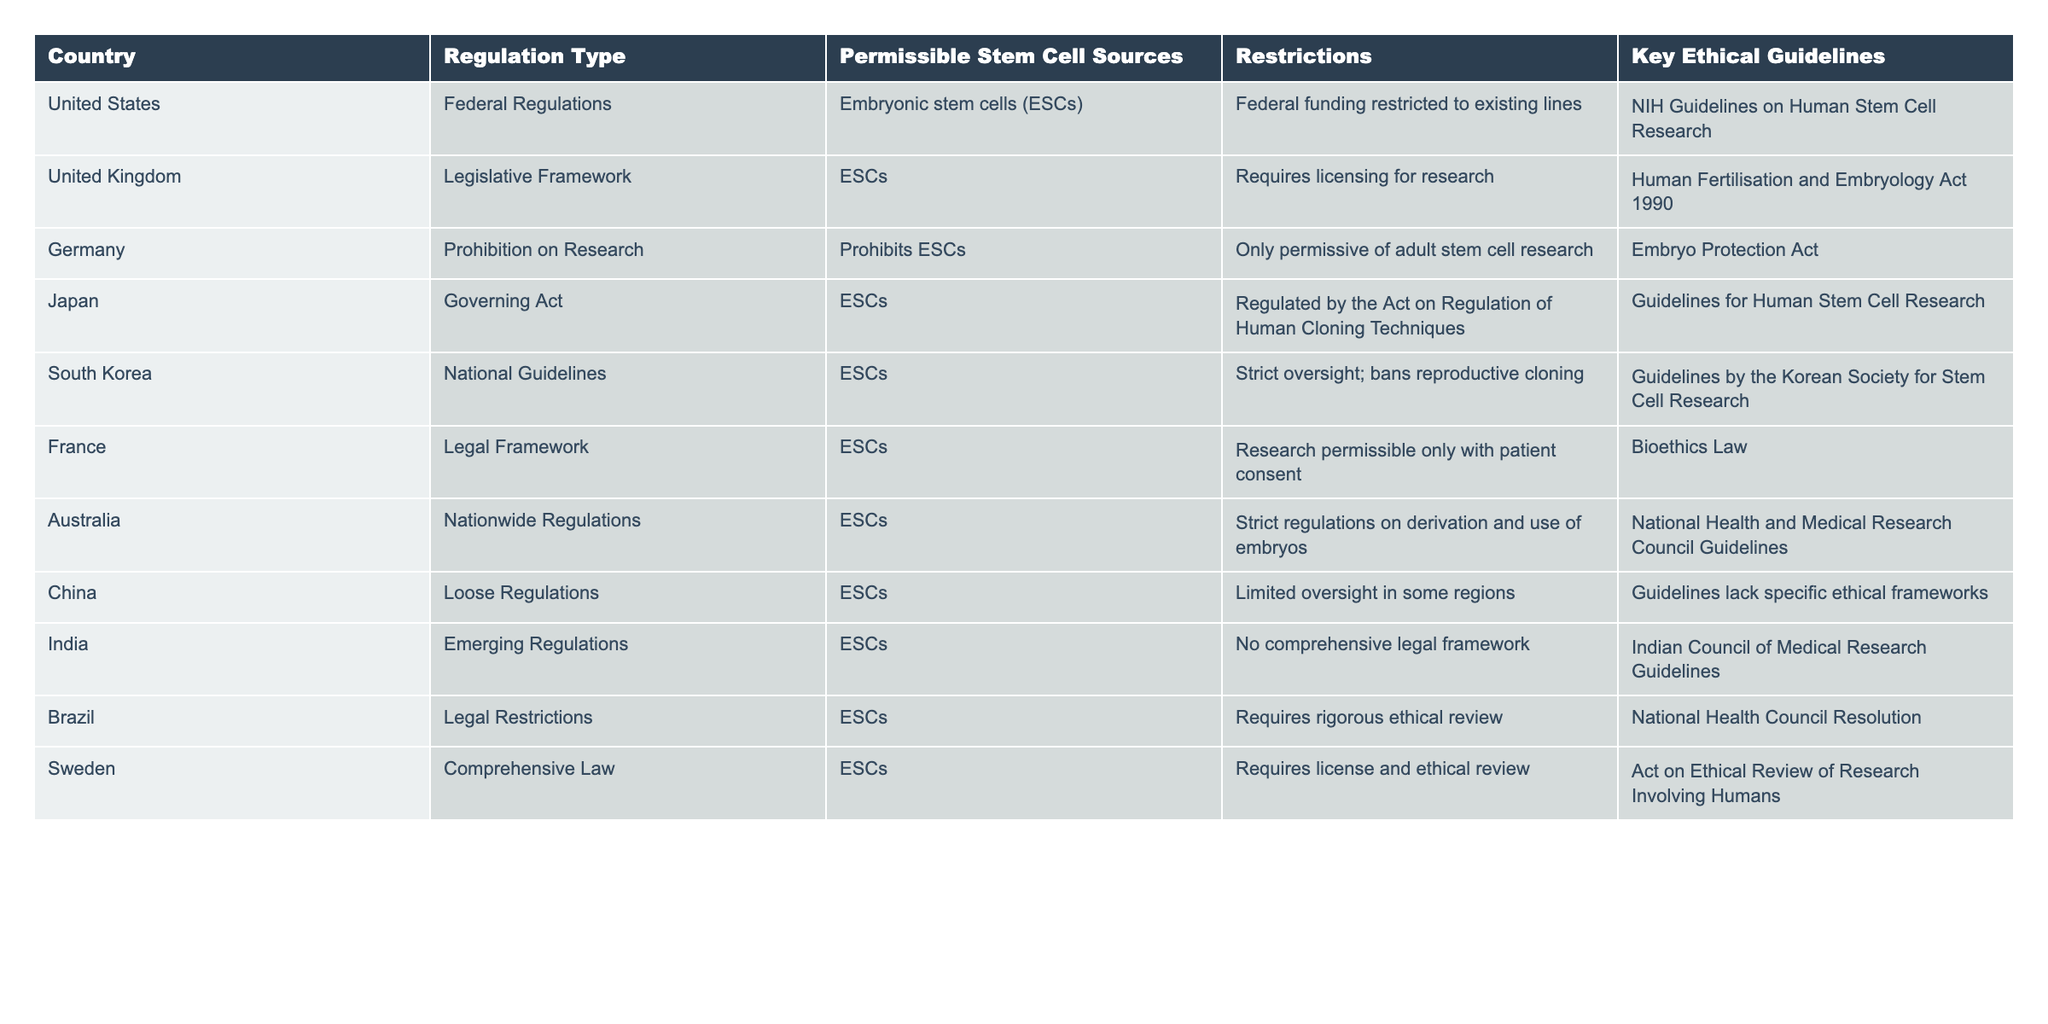What type of stem cell sources are permissible in the United States? According to the table, the United States permits embryonic stem cells as a source for research.
Answer: Embryonic stem cells What are the key ethical guidelines in Japan regarding stem cell research? The table indicates that Japan's key ethical guidelines are governed by the guidelines for Human Stem Cell Research.
Answer: Guidelines for Human Stem Cell Research Is research on embryonic stem cells allowed in Germany? The table states that Germany prohibits embryonic stem cell research.
Answer: No Which country has the strictest oversight for stem cell research regarding reproductive cloning? South Korea has strict oversight and explicitly bans reproductive cloning, according to the data.
Answer: South Korea How many countries require licensing for stem cell research? Based on the table, there are two countries that require licensing: the United Kingdom and Sweden.
Answer: Two Are comprehensive legal frameworks for stem cell research present in Brazil? The table shows that Brazil has legal restrictions but does not indicate a comprehensive framework.
Answer: No What is the difference in restrictions between the United States and Germany regarding embryonic stem cells? The United States restricts federal funding to existing lines, while Germany prohibits embryonic stem cell research altogether, allowing only adult stem cell research.
Answer: United States allows existing lines; Germany prohibits it Count the number of countries where adult stem cell research is not prohibited. The table indicates that adult stem cell research is unrestricted in the United States, United Kingdom, Japan, South Korea, Australia, India, and Sweden, totaling seven countries.
Answer: Seven Which country has the most permissive regulations regarding oversight? The table specifies that China has loose regulations with limited oversight in some regions, making it the most permissive.
Answer: China What restrictions exist in France for research permissible with patient consent? The table notes that France allows research on embryonic stem cells only with patient consent, indicating a specific ethical condition for permissibility.
Answer: Research allowed with patient consent Are there any countries in the table that completely prohibit embryonic stem cell research? The table clearly states that Germany prohibits embryonic stem cell research.
Answer: Yes, Germany 